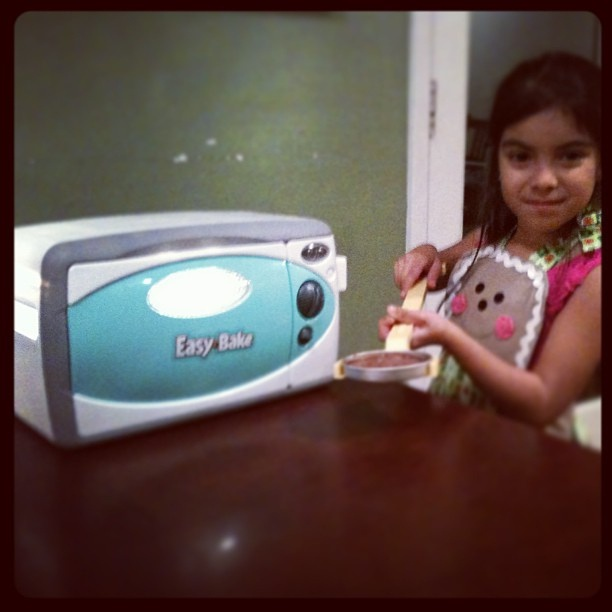Describe the objects in this image and their specific colors. I can see dining table in black, maroon, and gray tones, oven in black, lightgray, darkgray, teal, and gray tones, people in black, brown, maroon, and darkgray tones, and cake in black, gray, and darkgray tones in this image. 